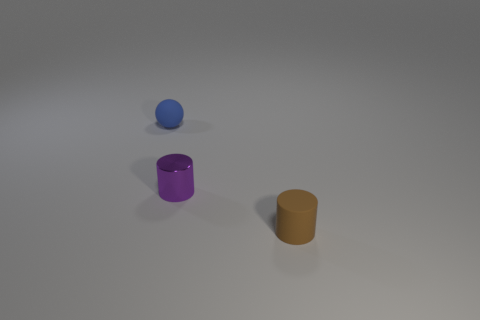Are there any other things that have the same material as the small purple cylinder?
Offer a very short reply. No. There is a small rubber thing on the left side of the matte thing in front of the tiny purple metal object behind the brown rubber object; what color is it?
Ensure brevity in your answer.  Blue. Is the material of the brown thing the same as the cylinder to the left of the tiny brown rubber object?
Ensure brevity in your answer.  No. What is the material of the small sphere?
Provide a short and direct response. Rubber. What number of other things are the same material as the purple cylinder?
Provide a succinct answer. 0. The tiny sphere that is made of the same material as the brown thing is what color?
Your answer should be very brief. Blue. Is the number of brown cylinders that are on the left side of the tiny matte ball the same as the number of purple shiny things?
Provide a short and direct response. No. There is a brown rubber thing that is the same size as the purple metal cylinder; what shape is it?
Keep it short and to the point. Cylinder. How many other objects are the same shape as the blue thing?
Your answer should be very brief. 0. There is a blue ball; is it the same size as the cylinder that is left of the small rubber cylinder?
Make the answer very short. Yes. 